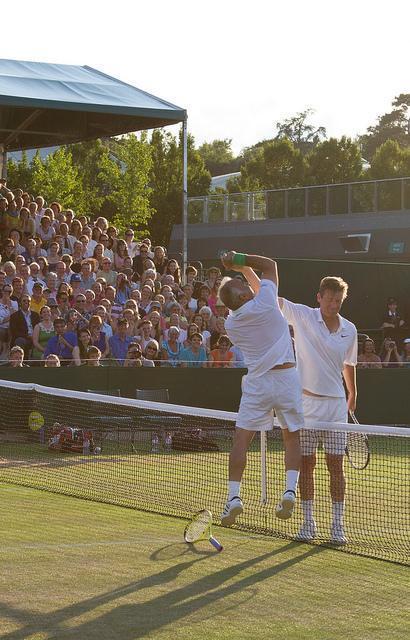How many people are there?
Give a very brief answer. 3. How many large giraffes are there?
Give a very brief answer. 0. 